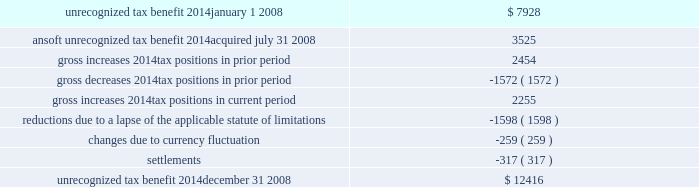The following is a reconciliation of the total amounts of unrecognized tax benefits for the year : ( in thousands ) .
Included in the balance of unrecognized tax benefits at december 31 , 2008 are $ 5.6 million of tax benefits that , if recognized , would affect the effective tax rate .
Also included in the balance of unrecognized tax benefits at december 31 , 2008 are $ 5.0 million of tax benefits that , if recognized , would result in a decrease to goodwill recorded in purchase business combinations , and $ 1.9 million of tax benefits that , if recognized , would result in adjustments to other tax accounts , primarily deferred taxes .
The company believes it is reasonably possible that uncertain tax positions of approximately $ 2.6 million as of december 31 , 2008 will be resolved within the next twelve months .
The company recognizes interest and penalties related to unrecognized tax benefits as income tax expense .
Related to the uncertain tax benefits noted above , the company recorded interest of $ 171000 during 2008 .
Penalties recorded during 2008 were insignificant .
In total , as of december 31 , 2008 , the company has recognized a liability for penalties of $ 498000 and interest of $ 1.8 million .
The company is subject to taxation in the u.s .
And various states and foreign jurisdictions .
The company 2019s 2005 through 2008 tax years are open to examination by the internal revenue service .
The 2005 and 2006 federal returns are currently under examination .
The company also has various foreign subsidiaries with tax filings under examination , as well as numerous foreign and state tax filings subject to examination for various years .
10 .
Pension and profit-sharing plans the company has 401 ( k ) /profit-sharing plans for all qualifying full-time domestic employees that permit participants to make contributions by salary reduction pursuant to section 401 ( k ) of the internal revenue code .
The company makes matching contributions on behalf of each eligible participant in an amount equal to 100% ( 100 % ) of the first 3% ( 3 % ) and an additional 25% ( 25 % ) of the next 5% ( 5 % ) , for a maximum total of 4.25% ( 4.25 % ) of the employee 2019s compensation .
The company may make a discretionary profit sharing contribution in the amount of 0% ( 0 % ) to 5% ( 5 % ) based on the participant 2019s eligible compensation , provided the employee is employed at the end of the year and has worked at least 1000 hours .
The qualifying domestic employees of the company 2019s ansoft subsidiary , acquired on july 31 , 2008 , also participate in a 401 ( k ) plan .
There is no matching employer contribution associated with this plan .
The company also maintains various defined contribution pension arrangements for its international employees .
Expenses related to the company 2019s retirement programs were $ 3.7 million in 2008 , $ 4.7 million in 2007 and $ 4.1 million in 2006 .
11 .
Non-compete and employment agreements employees of the company have signed agreements under which they have agreed not to disclose trade secrets or confidential information and , where legally permitted , that restrict engagement in or connection with any business that is competitive with the company anywhere in the world while employed by the company ( and .
What is the percentage increase in unrecognized tax benefits from jan 2008-dec 2008? 
Computations: ((12416 - 7928) / 7928)
Answer: 0.56609. 